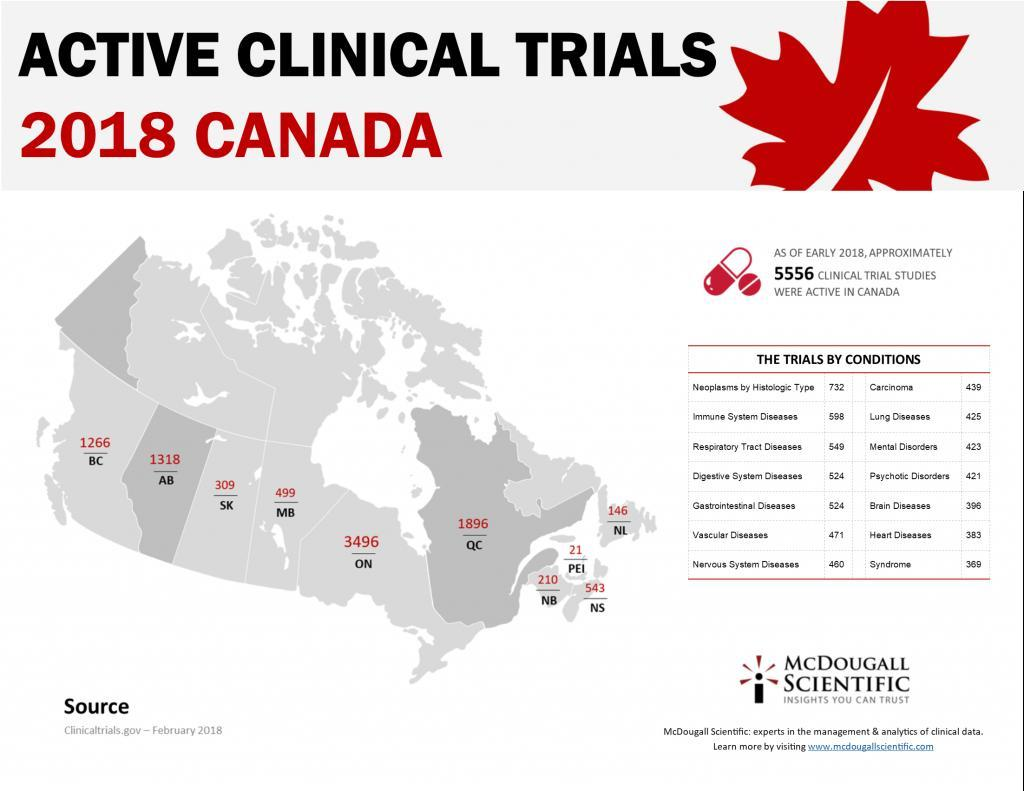for which disease more clinical trials have been conducted - brain diseases or heart diseases?
Answer the question with a short phrase. brain diseases for which disease more clinical trials have been conducted - mental disorders or psychotic disorders? mental disorders what is the number of clinical trial studies on gastrointestinal diseases and digestive system diseases combined? 1048 what is the number of clinical trial studies on mental disorders and psychotic disorders combined? 844 what is the number of clinical trial studies on respiratory tract diseases and digestive system diseases combined? 1073 For which two diseases have equal number of trials conducted? gastrointestinal diseases, digestive system diseases for which disease more clinical trials have been conducted - respiratory tract diseases or immune system diseases? immune system diseases what is the number of clinical trial studies on brain diseases and heart diseases combined? 779 for which disease more clinical trials have been conducted - vascular diseases or heart diseases? vascular diseases what is the number of clinical trial studies on respiratory tract diseases and immune system diseases combined? 1147 